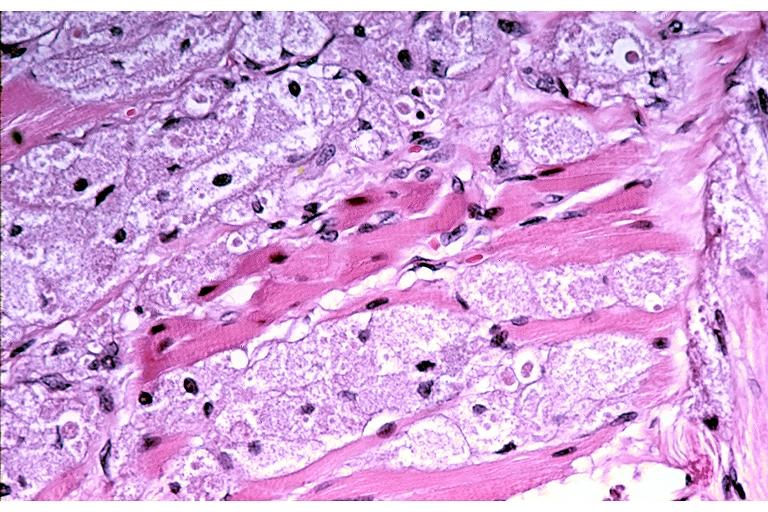where is this?
Answer the question using a single word or phrase. Oral 